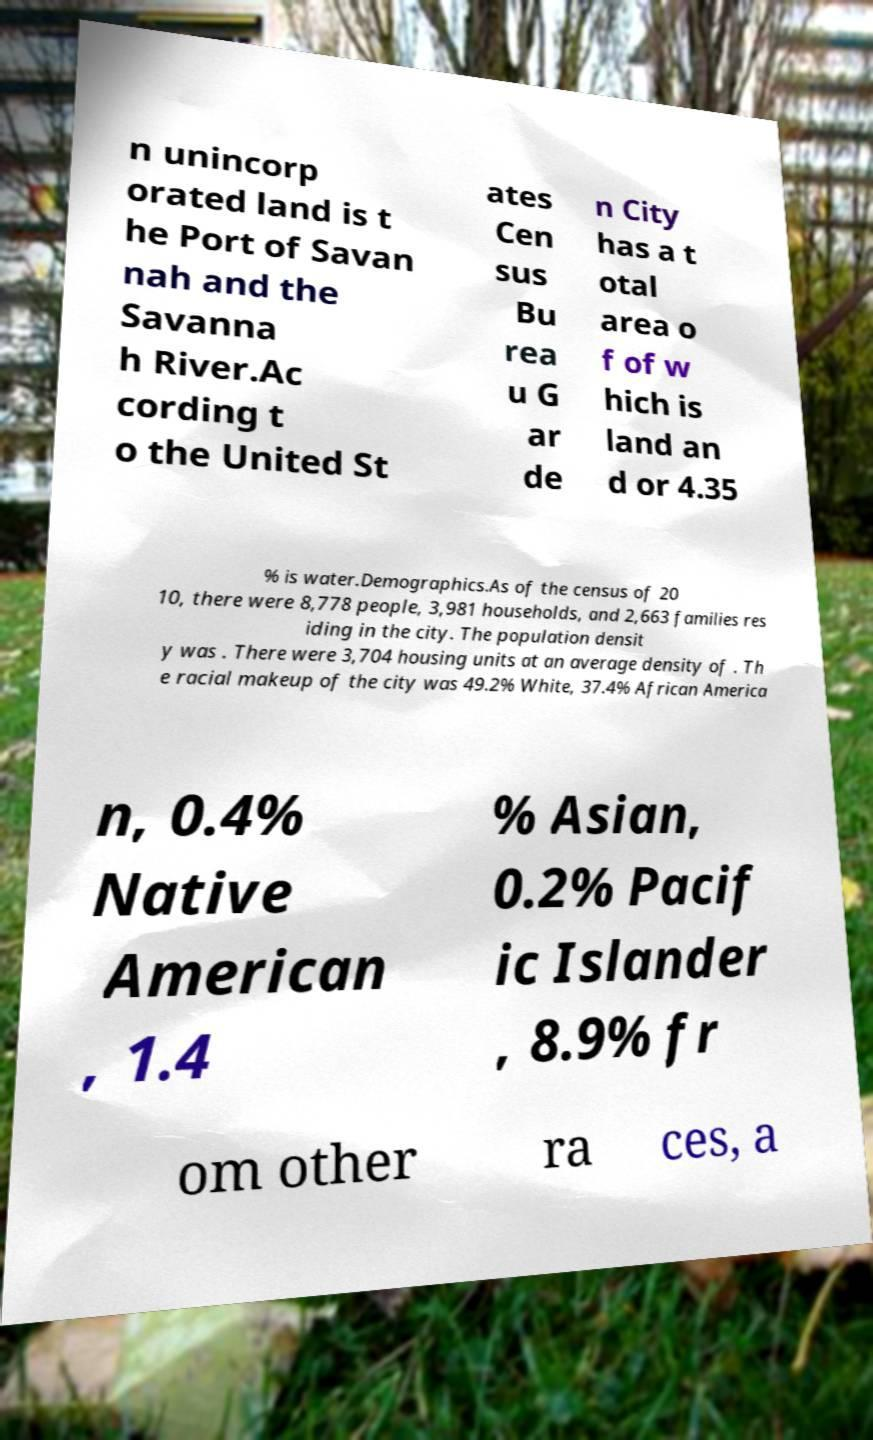What messages or text are displayed in this image? I need them in a readable, typed format. n unincorp orated land is t he Port of Savan nah and the Savanna h River.Ac cording t o the United St ates Cen sus Bu rea u G ar de n City has a t otal area o f of w hich is land an d or 4.35 % is water.Demographics.As of the census of 20 10, there were 8,778 people, 3,981 households, and 2,663 families res iding in the city. The population densit y was . There were 3,704 housing units at an average density of . Th e racial makeup of the city was 49.2% White, 37.4% African America n, 0.4% Native American , 1.4 % Asian, 0.2% Pacif ic Islander , 8.9% fr om other ra ces, a 